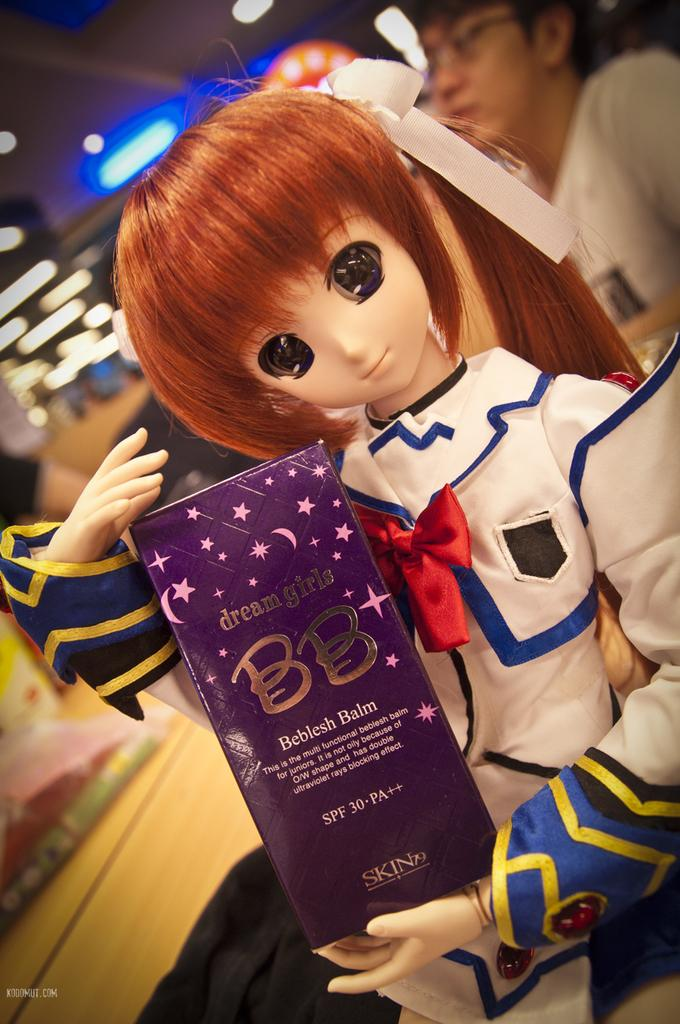What is the main subject of the image? There is a doll in the image. What is the doll holding? The doll is holding a blue color box. Can you describe the background of the image? There is a person and light visible in the background of the image. How many glasses are on the table in the image? There is no table or glasses present in the image; it features a doll holding a blue color box. Can you describe the person's sneeze in the background of the image? There is no sneeze or indication of a sneeze in the image; it only shows a person and light in the background. 